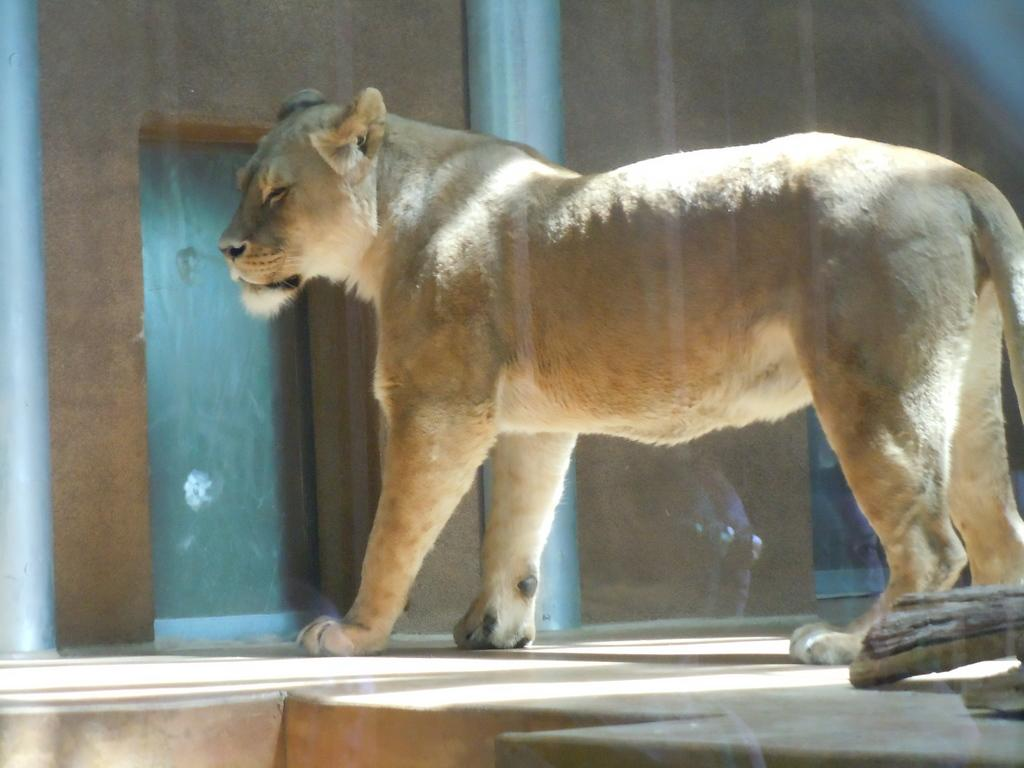What type of creature is in the image? There is an animal in the image. Where is the animal located in the image? The animal is on the floor. What can be seen in the background of the image? There is a building in the background of the image. What type of juice is the animal drinking in the image? There is no juice present in the image, and the animal is not shown drinking anything. 